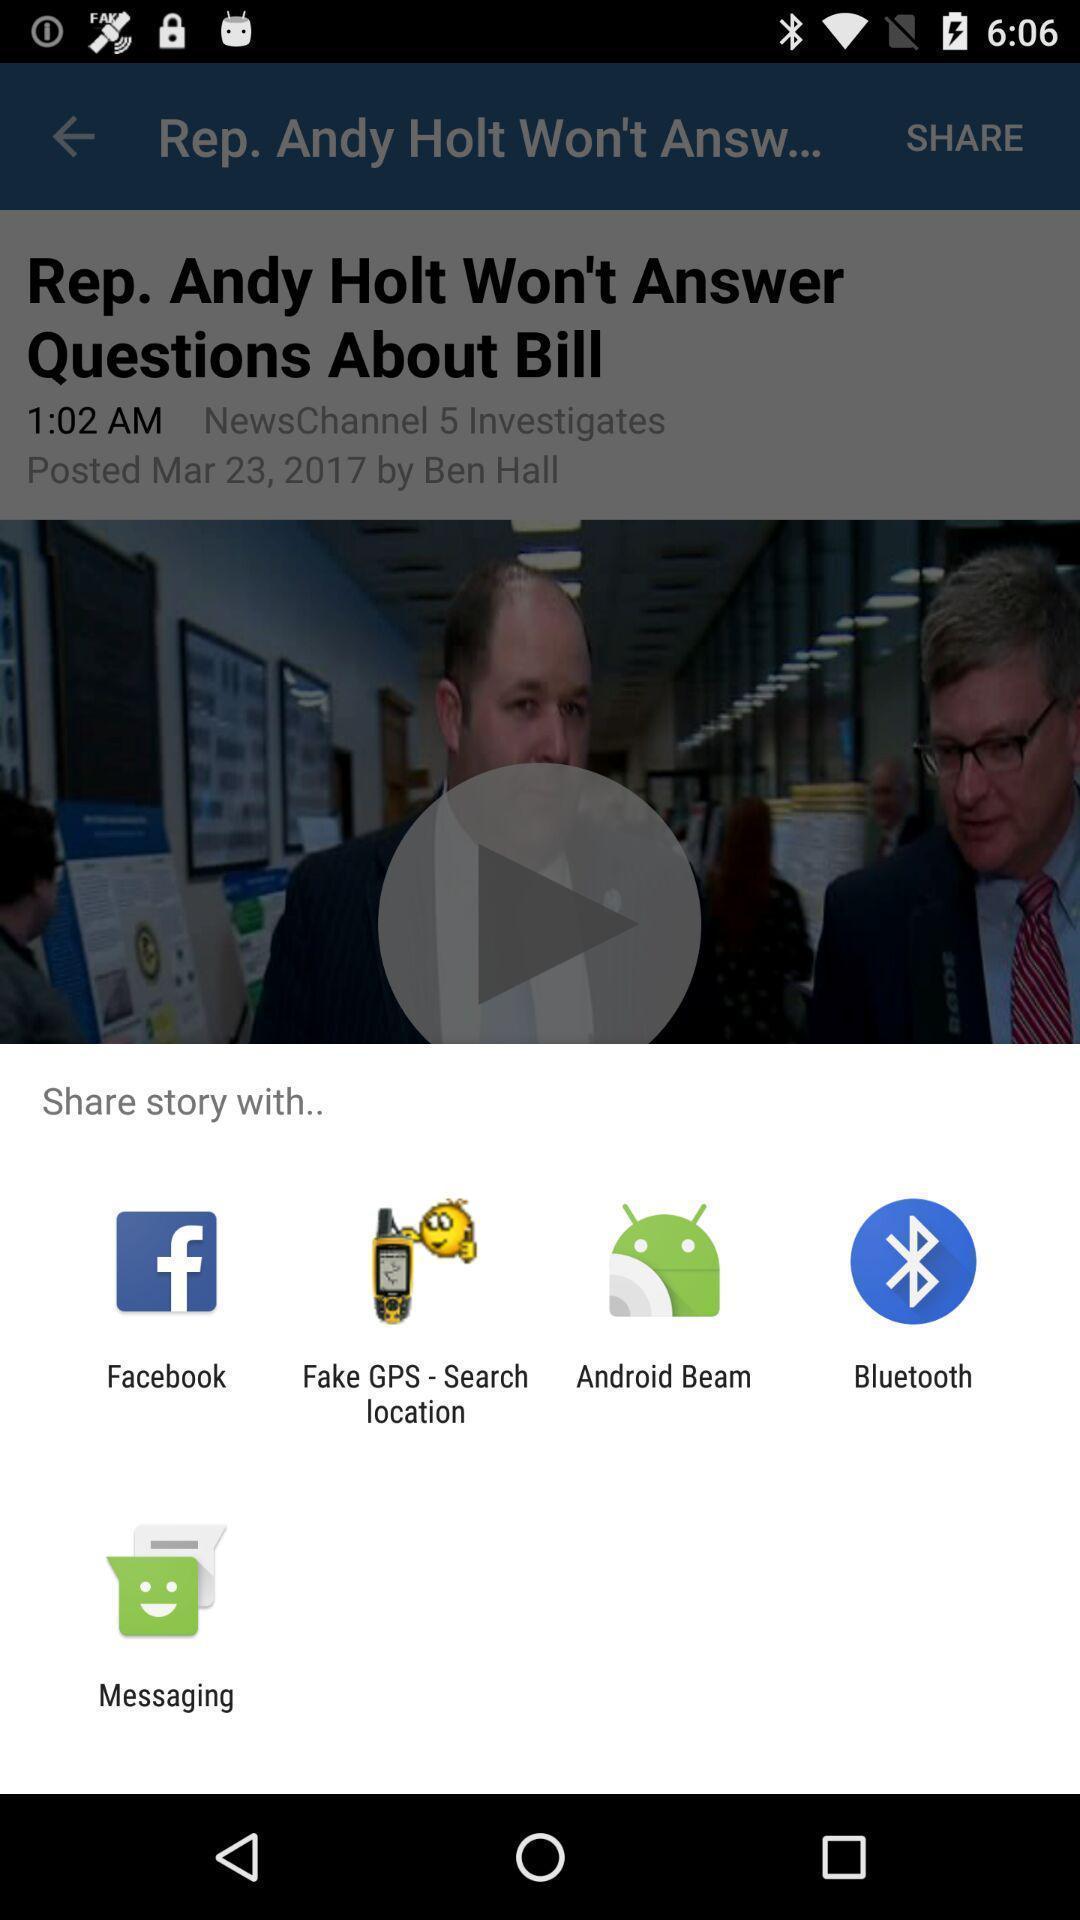Please provide a description for this image. Pop-up to share story via different social apps. 